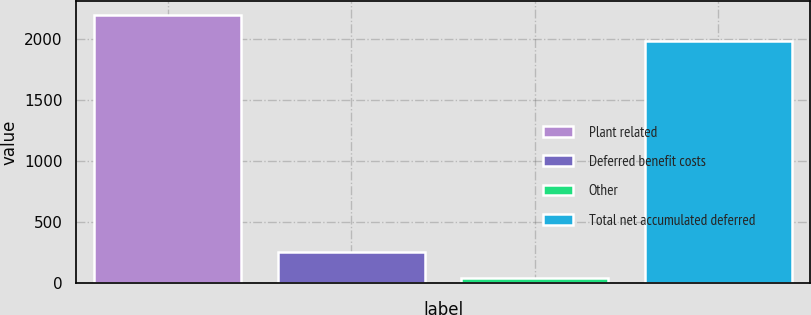<chart> <loc_0><loc_0><loc_500><loc_500><bar_chart><fcel>Plant related<fcel>Deferred benefit costs<fcel>Other<fcel>Total net accumulated deferred<nl><fcel>2197.7<fcel>253.7<fcel>39<fcel>1983<nl></chart> 